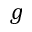Convert formula to latex. <formula><loc_0><loc_0><loc_500><loc_500>g</formula> 